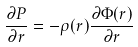Convert formula to latex. <formula><loc_0><loc_0><loc_500><loc_500>\frac { \partial P } { \partial r } = - \rho ( r ) \frac { \partial \Phi ( r ) } { \partial r }</formula> 